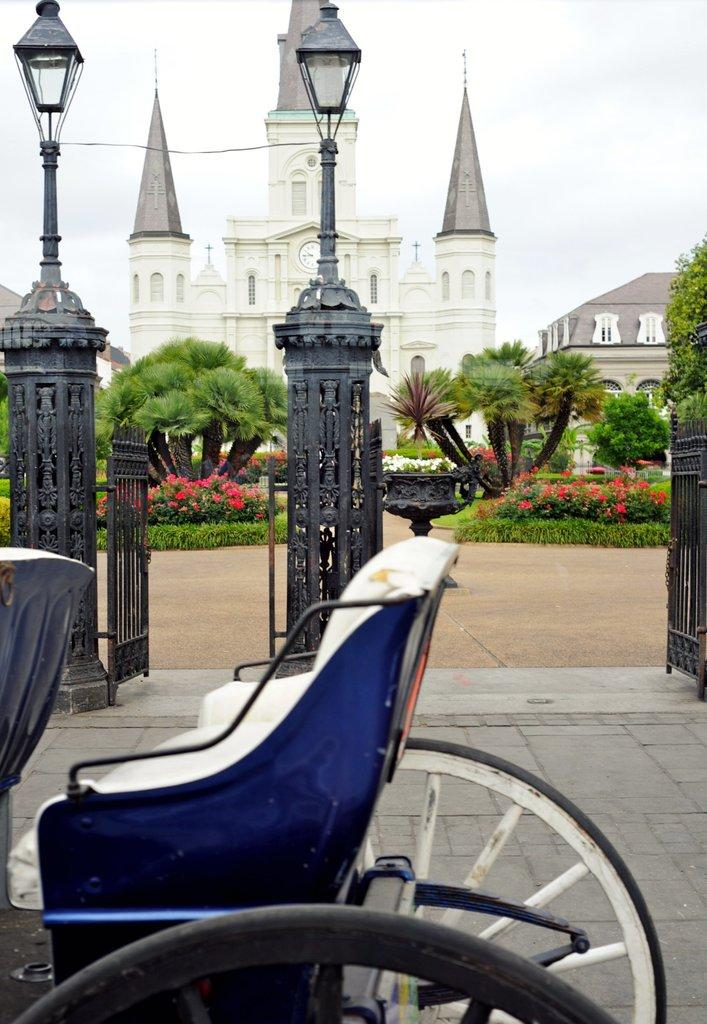What type of structure can be seen in the image? There is a building in the image. What is the purpose of the street light in the image? The street light provides illumination in the image. What type of vegetation is present in the image? There are trees and plants in the image. What time-keeping device is visible in the image? There is a wall clock in the image. What mode of transportation is present in the image? There is a vehicle in the image. What can be seen in the background of the image? There are clouds and the sky visible in the background of the image. What type of pizzas are being served at the farm in the image? There is no farm or pizzas present in the image. What brand of toothpaste is being advertised on the wall clock in the image? There is no toothpaste or advertisement present on the wall clock in the image. 